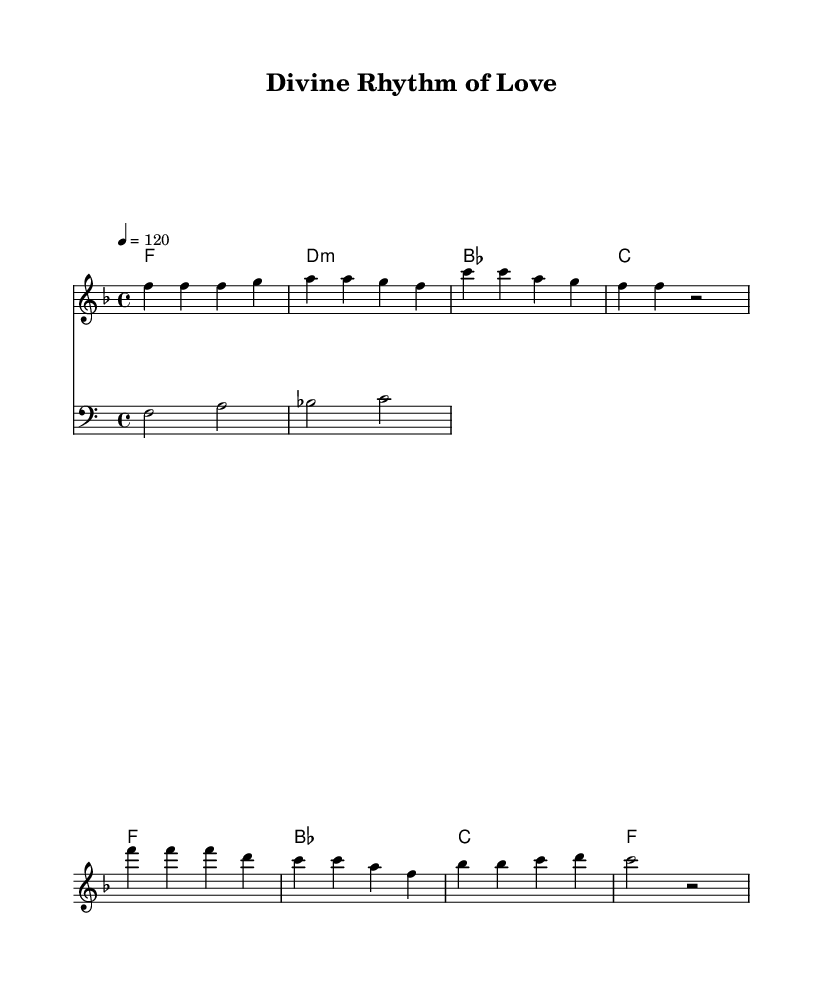What is the key signature of this music? The key signature is F major, which has one flat (B flat). It can be determined by looking at the key signature at the beginning of the staff where the flat symbol is indicated.
Answer: F major What is the time signature of this piece? The time signature is 4/4, indicating four beats in each measure and a quarter note receives one beat. This can be found at the start of the music, represented as two numbers stacked vertically.
Answer: 4/4 What is the tempo marking for this music? The tempo marking is 120 beats per minute, shown as "4 = 120". This tells us how fast the piece should be played, with the number representing the number of beats per minute and the quarter note receiving the beat.
Answer: 120 How many measures are in the verse section? The verse section contains four measures. This can be confirmed by counting the bar lines marked in the melody part for the verse, which shows a total of four distinct segments.
Answer: 4 What do the lyrics in the chorus emphasize? The lyrics in the chorus emphasize the divine rhythm of love. This is evident from the section of lyrics directly associated with the chorus melody, highlighting positive and uplifting feelings associated with spiritual themes.
Answer: Divine rhythm of love What is the main theme reflected in the lyrics? The main theme reflected in the lyrics is finding guidance and presence through faith. The lyrics describe a journey and connection with the divine, which resonates with spiritual upliftment and encouragement through life's experiences.
Answer: Guidance and presence through faith What kind of accompaniment is used in this piece? The accompaniment for this piece consists of chords and a bass line. The chord progression can be observed alongside the melody, which provides harmonic support, while the bass line adds depth beneath the melodic line.
Answer: Chords and bass line 